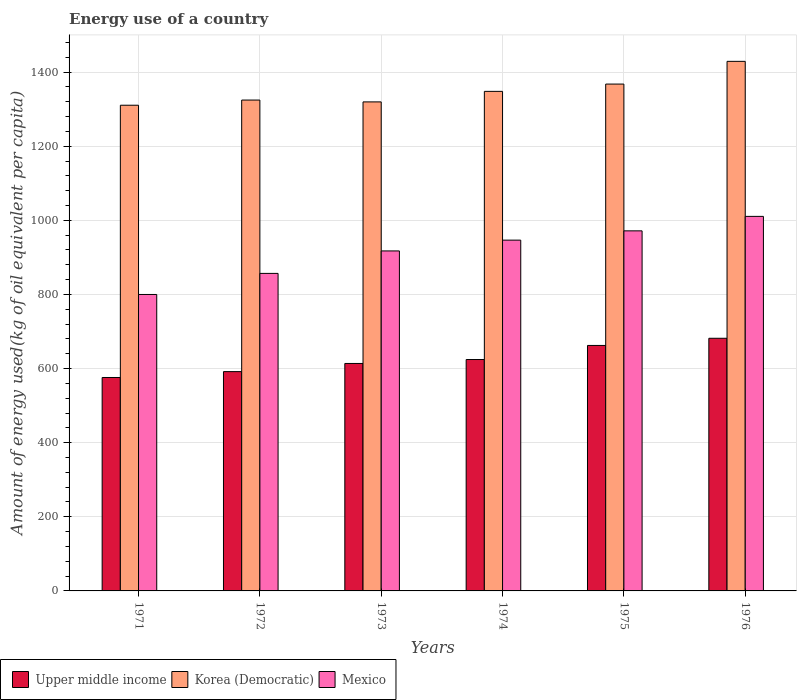How many different coloured bars are there?
Your response must be concise. 3. How many groups of bars are there?
Your response must be concise. 6. Are the number of bars per tick equal to the number of legend labels?
Keep it short and to the point. Yes. How many bars are there on the 4th tick from the left?
Your answer should be very brief. 3. How many bars are there on the 5th tick from the right?
Offer a terse response. 3. What is the label of the 5th group of bars from the left?
Your answer should be very brief. 1975. What is the amount of energy used in in Korea (Democratic) in 1971?
Provide a succinct answer. 1310.63. Across all years, what is the maximum amount of energy used in in Upper middle income?
Offer a very short reply. 681.74. Across all years, what is the minimum amount of energy used in in Korea (Democratic)?
Your answer should be compact. 1310.63. In which year was the amount of energy used in in Mexico maximum?
Ensure brevity in your answer.  1976. In which year was the amount of energy used in in Korea (Democratic) minimum?
Keep it short and to the point. 1971. What is the total amount of energy used in in Mexico in the graph?
Make the answer very short. 5503.14. What is the difference between the amount of energy used in in Upper middle income in 1972 and that in 1975?
Offer a terse response. -70.61. What is the difference between the amount of energy used in in Mexico in 1974 and the amount of energy used in in Upper middle income in 1972?
Offer a terse response. 354.8. What is the average amount of energy used in in Korea (Democratic) per year?
Give a very brief answer. 1349.94. In the year 1975, what is the difference between the amount of energy used in in Korea (Democratic) and amount of energy used in in Upper middle income?
Your answer should be very brief. 705.3. In how many years, is the amount of energy used in in Korea (Democratic) greater than 800 kg?
Ensure brevity in your answer.  6. What is the ratio of the amount of energy used in in Mexico in 1974 to that in 1975?
Give a very brief answer. 0.97. Is the amount of energy used in in Upper middle income in 1971 less than that in 1974?
Your response must be concise. Yes. What is the difference between the highest and the second highest amount of energy used in in Upper middle income?
Offer a terse response. 19.33. What is the difference between the highest and the lowest amount of energy used in in Mexico?
Provide a succinct answer. 210.75. In how many years, is the amount of energy used in in Korea (Democratic) greater than the average amount of energy used in in Korea (Democratic) taken over all years?
Your response must be concise. 2. What does the 2nd bar from the right in 1976 represents?
Provide a succinct answer. Korea (Democratic). Are all the bars in the graph horizontal?
Give a very brief answer. No. What is the difference between two consecutive major ticks on the Y-axis?
Provide a short and direct response. 200. Does the graph contain grids?
Offer a very short reply. Yes. What is the title of the graph?
Your answer should be very brief. Energy use of a country. What is the label or title of the X-axis?
Offer a very short reply. Years. What is the label or title of the Y-axis?
Make the answer very short. Amount of energy used(kg of oil equivalent per capita). What is the Amount of energy used(kg of oil equivalent per capita) of Upper middle income in 1971?
Offer a terse response. 575.93. What is the Amount of energy used(kg of oil equivalent per capita) of Korea (Democratic) in 1971?
Your response must be concise. 1310.63. What is the Amount of energy used(kg of oil equivalent per capita) of Mexico in 1971?
Your answer should be compact. 799.94. What is the Amount of energy used(kg of oil equivalent per capita) of Upper middle income in 1972?
Offer a very short reply. 591.8. What is the Amount of energy used(kg of oil equivalent per capita) of Korea (Democratic) in 1972?
Provide a short and direct response. 1324.59. What is the Amount of energy used(kg of oil equivalent per capita) of Mexico in 1972?
Your answer should be compact. 856.81. What is the Amount of energy used(kg of oil equivalent per capita) in Upper middle income in 1973?
Provide a short and direct response. 613.81. What is the Amount of energy used(kg of oil equivalent per capita) of Korea (Democratic) in 1973?
Give a very brief answer. 1319.63. What is the Amount of energy used(kg of oil equivalent per capita) of Mexico in 1973?
Your answer should be very brief. 917.47. What is the Amount of energy used(kg of oil equivalent per capita) in Upper middle income in 1974?
Provide a short and direct response. 624.42. What is the Amount of energy used(kg of oil equivalent per capita) of Korea (Democratic) in 1974?
Your answer should be compact. 1348.04. What is the Amount of energy used(kg of oil equivalent per capita) in Mexico in 1974?
Offer a terse response. 946.6. What is the Amount of energy used(kg of oil equivalent per capita) in Upper middle income in 1975?
Offer a terse response. 662.41. What is the Amount of energy used(kg of oil equivalent per capita) in Korea (Democratic) in 1975?
Ensure brevity in your answer.  1367.71. What is the Amount of energy used(kg of oil equivalent per capita) in Mexico in 1975?
Your answer should be very brief. 971.61. What is the Amount of energy used(kg of oil equivalent per capita) in Upper middle income in 1976?
Provide a succinct answer. 681.74. What is the Amount of energy used(kg of oil equivalent per capita) in Korea (Democratic) in 1976?
Offer a terse response. 1429.02. What is the Amount of energy used(kg of oil equivalent per capita) in Mexico in 1976?
Provide a succinct answer. 1010.7. Across all years, what is the maximum Amount of energy used(kg of oil equivalent per capita) of Upper middle income?
Provide a short and direct response. 681.74. Across all years, what is the maximum Amount of energy used(kg of oil equivalent per capita) in Korea (Democratic)?
Provide a short and direct response. 1429.02. Across all years, what is the maximum Amount of energy used(kg of oil equivalent per capita) in Mexico?
Your answer should be very brief. 1010.7. Across all years, what is the minimum Amount of energy used(kg of oil equivalent per capita) of Upper middle income?
Provide a short and direct response. 575.93. Across all years, what is the minimum Amount of energy used(kg of oil equivalent per capita) in Korea (Democratic)?
Ensure brevity in your answer.  1310.63. Across all years, what is the minimum Amount of energy used(kg of oil equivalent per capita) in Mexico?
Your response must be concise. 799.94. What is the total Amount of energy used(kg of oil equivalent per capita) of Upper middle income in the graph?
Provide a succinct answer. 3750.12. What is the total Amount of energy used(kg of oil equivalent per capita) of Korea (Democratic) in the graph?
Keep it short and to the point. 8099.61. What is the total Amount of energy used(kg of oil equivalent per capita) of Mexico in the graph?
Give a very brief answer. 5503.14. What is the difference between the Amount of energy used(kg of oil equivalent per capita) of Upper middle income in 1971 and that in 1972?
Offer a very short reply. -15.87. What is the difference between the Amount of energy used(kg of oil equivalent per capita) of Korea (Democratic) in 1971 and that in 1972?
Ensure brevity in your answer.  -13.96. What is the difference between the Amount of energy used(kg of oil equivalent per capita) in Mexico in 1971 and that in 1972?
Offer a very short reply. -56.87. What is the difference between the Amount of energy used(kg of oil equivalent per capita) of Upper middle income in 1971 and that in 1973?
Offer a very short reply. -37.88. What is the difference between the Amount of energy used(kg of oil equivalent per capita) in Korea (Democratic) in 1971 and that in 1973?
Make the answer very short. -9. What is the difference between the Amount of energy used(kg of oil equivalent per capita) in Mexico in 1971 and that in 1973?
Offer a very short reply. -117.53. What is the difference between the Amount of energy used(kg of oil equivalent per capita) of Upper middle income in 1971 and that in 1974?
Offer a very short reply. -48.49. What is the difference between the Amount of energy used(kg of oil equivalent per capita) of Korea (Democratic) in 1971 and that in 1974?
Your response must be concise. -37.41. What is the difference between the Amount of energy used(kg of oil equivalent per capita) of Mexico in 1971 and that in 1974?
Your answer should be very brief. -146.66. What is the difference between the Amount of energy used(kg of oil equivalent per capita) of Upper middle income in 1971 and that in 1975?
Your answer should be very brief. -86.48. What is the difference between the Amount of energy used(kg of oil equivalent per capita) in Korea (Democratic) in 1971 and that in 1975?
Offer a very short reply. -57.08. What is the difference between the Amount of energy used(kg of oil equivalent per capita) in Mexico in 1971 and that in 1975?
Your answer should be compact. -171.67. What is the difference between the Amount of energy used(kg of oil equivalent per capita) in Upper middle income in 1971 and that in 1976?
Offer a very short reply. -105.81. What is the difference between the Amount of energy used(kg of oil equivalent per capita) of Korea (Democratic) in 1971 and that in 1976?
Ensure brevity in your answer.  -118.39. What is the difference between the Amount of energy used(kg of oil equivalent per capita) in Mexico in 1971 and that in 1976?
Keep it short and to the point. -210.75. What is the difference between the Amount of energy used(kg of oil equivalent per capita) in Upper middle income in 1972 and that in 1973?
Offer a terse response. -22.02. What is the difference between the Amount of energy used(kg of oil equivalent per capita) in Korea (Democratic) in 1972 and that in 1973?
Offer a terse response. 4.97. What is the difference between the Amount of energy used(kg of oil equivalent per capita) in Mexico in 1972 and that in 1973?
Your answer should be very brief. -60.66. What is the difference between the Amount of energy used(kg of oil equivalent per capita) of Upper middle income in 1972 and that in 1974?
Your response must be concise. -32.63. What is the difference between the Amount of energy used(kg of oil equivalent per capita) of Korea (Democratic) in 1972 and that in 1974?
Ensure brevity in your answer.  -23.44. What is the difference between the Amount of energy used(kg of oil equivalent per capita) in Mexico in 1972 and that in 1974?
Keep it short and to the point. -89.79. What is the difference between the Amount of energy used(kg of oil equivalent per capita) in Upper middle income in 1972 and that in 1975?
Ensure brevity in your answer.  -70.61. What is the difference between the Amount of energy used(kg of oil equivalent per capita) in Korea (Democratic) in 1972 and that in 1975?
Give a very brief answer. -43.12. What is the difference between the Amount of energy used(kg of oil equivalent per capita) of Mexico in 1972 and that in 1975?
Keep it short and to the point. -114.8. What is the difference between the Amount of energy used(kg of oil equivalent per capita) in Upper middle income in 1972 and that in 1976?
Offer a terse response. -89.94. What is the difference between the Amount of energy used(kg of oil equivalent per capita) in Korea (Democratic) in 1972 and that in 1976?
Ensure brevity in your answer.  -104.43. What is the difference between the Amount of energy used(kg of oil equivalent per capita) of Mexico in 1972 and that in 1976?
Your answer should be very brief. -153.89. What is the difference between the Amount of energy used(kg of oil equivalent per capita) in Upper middle income in 1973 and that in 1974?
Your answer should be compact. -10.61. What is the difference between the Amount of energy used(kg of oil equivalent per capita) of Korea (Democratic) in 1973 and that in 1974?
Offer a terse response. -28.41. What is the difference between the Amount of energy used(kg of oil equivalent per capita) in Mexico in 1973 and that in 1974?
Your answer should be compact. -29.13. What is the difference between the Amount of energy used(kg of oil equivalent per capita) of Upper middle income in 1973 and that in 1975?
Your answer should be compact. -48.6. What is the difference between the Amount of energy used(kg of oil equivalent per capita) of Korea (Democratic) in 1973 and that in 1975?
Ensure brevity in your answer.  -48.08. What is the difference between the Amount of energy used(kg of oil equivalent per capita) in Mexico in 1973 and that in 1975?
Your response must be concise. -54.14. What is the difference between the Amount of energy used(kg of oil equivalent per capita) of Upper middle income in 1973 and that in 1976?
Your answer should be very brief. -67.93. What is the difference between the Amount of energy used(kg of oil equivalent per capita) of Korea (Democratic) in 1973 and that in 1976?
Your answer should be very brief. -109.39. What is the difference between the Amount of energy used(kg of oil equivalent per capita) in Mexico in 1973 and that in 1976?
Ensure brevity in your answer.  -93.23. What is the difference between the Amount of energy used(kg of oil equivalent per capita) of Upper middle income in 1974 and that in 1975?
Provide a succinct answer. -37.99. What is the difference between the Amount of energy used(kg of oil equivalent per capita) of Korea (Democratic) in 1974 and that in 1975?
Your response must be concise. -19.67. What is the difference between the Amount of energy used(kg of oil equivalent per capita) of Mexico in 1974 and that in 1975?
Give a very brief answer. -25.01. What is the difference between the Amount of energy used(kg of oil equivalent per capita) of Upper middle income in 1974 and that in 1976?
Your response must be concise. -57.32. What is the difference between the Amount of energy used(kg of oil equivalent per capita) in Korea (Democratic) in 1974 and that in 1976?
Keep it short and to the point. -80.98. What is the difference between the Amount of energy used(kg of oil equivalent per capita) in Mexico in 1974 and that in 1976?
Keep it short and to the point. -64.1. What is the difference between the Amount of energy used(kg of oil equivalent per capita) in Upper middle income in 1975 and that in 1976?
Your answer should be compact. -19.33. What is the difference between the Amount of energy used(kg of oil equivalent per capita) of Korea (Democratic) in 1975 and that in 1976?
Your answer should be very brief. -61.31. What is the difference between the Amount of energy used(kg of oil equivalent per capita) of Mexico in 1975 and that in 1976?
Keep it short and to the point. -39.08. What is the difference between the Amount of energy used(kg of oil equivalent per capita) of Upper middle income in 1971 and the Amount of energy used(kg of oil equivalent per capita) of Korea (Democratic) in 1972?
Your response must be concise. -748.66. What is the difference between the Amount of energy used(kg of oil equivalent per capita) of Upper middle income in 1971 and the Amount of energy used(kg of oil equivalent per capita) of Mexico in 1972?
Ensure brevity in your answer.  -280.88. What is the difference between the Amount of energy used(kg of oil equivalent per capita) of Korea (Democratic) in 1971 and the Amount of energy used(kg of oil equivalent per capita) of Mexico in 1972?
Your response must be concise. 453.82. What is the difference between the Amount of energy used(kg of oil equivalent per capita) in Upper middle income in 1971 and the Amount of energy used(kg of oil equivalent per capita) in Korea (Democratic) in 1973?
Offer a terse response. -743.69. What is the difference between the Amount of energy used(kg of oil equivalent per capita) of Upper middle income in 1971 and the Amount of energy used(kg of oil equivalent per capita) of Mexico in 1973?
Offer a very short reply. -341.54. What is the difference between the Amount of energy used(kg of oil equivalent per capita) in Korea (Democratic) in 1971 and the Amount of energy used(kg of oil equivalent per capita) in Mexico in 1973?
Your response must be concise. 393.16. What is the difference between the Amount of energy used(kg of oil equivalent per capita) in Upper middle income in 1971 and the Amount of energy used(kg of oil equivalent per capita) in Korea (Democratic) in 1974?
Your response must be concise. -772.11. What is the difference between the Amount of energy used(kg of oil equivalent per capita) of Upper middle income in 1971 and the Amount of energy used(kg of oil equivalent per capita) of Mexico in 1974?
Provide a succinct answer. -370.67. What is the difference between the Amount of energy used(kg of oil equivalent per capita) of Korea (Democratic) in 1971 and the Amount of energy used(kg of oil equivalent per capita) of Mexico in 1974?
Provide a short and direct response. 364.03. What is the difference between the Amount of energy used(kg of oil equivalent per capita) in Upper middle income in 1971 and the Amount of energy used(kg of oil equivalent per capita) in Korea (Democratic) in 1975?
Give a very brief answer. -791.78. What is the difference between the Amount of energy used(kg of oil equivalent per capita) in Upper middle income in 1971 and the Amount of energy used(kg of oil equivalent per capita) in Mexico in 1975?
Your answer should be very brief. -395.68. What is the difference between the Amount of energy used(kg of oil equivalent per capita) in Korea (Democratic) in 1971 and the Amount of energy used(kg of oil equivalent per capita) in Mexico in 1975?
Keep it short and to the point. 339.01. What is the difference between the Amount of energy used(kg of oil equivalent per capita) of Upper middle income in 1971 and the Amount of energy used(kg of oil equivalent per capita) of Korea (Democratic) in 1976?
Your answer should be compact. -853.09. What is the difference between the Amount of energy used(kg of oil equivalent per capita) of Upper middle income in 1971 and the Amount of energy used(kg of oil equivalent per capita) of Mexico in 1976?
Your response must be concise. -434.77. What is the difference between the Amount of energy used(kg of oil equivalent per capita) of Korea (Democratic) in 1971 and the Amount of energy used(kg of oil equivalent per capita) of Mexico in 1976?
Provide a short and direct response. 299.93. What is the difference between the Amount of energy used(kg of oil equivalent per capita) in Upper middle income in 1972 and the Amount of energy used(kg of oil equivalent per capita) in Korea (Democratic) in 1973?
Provide a short and direct response. -727.83. What is the difference between the Amount of energy used(kg of oil equivalent per capita) of Upper middle income in 1972 and the Amount of energy used(kg of oil equivalent per capita) of Mexico in 1973?
Your response must be concise. -325.67. What is the difference between the Amount of energy used(kg of oil equivalent per capita) of Korea (Democratic) in 1972 and the Amount of energy used(kg of oil equivalent per capita) of Mexico in 1973?
Offer a very short reply. 407.12. What is the difference between the Amount of energy used(kg of oil equivalent per capita) in Upper middle income in 1972 and the Amount of energy used(kg of oil equivalent per capita) in Korea (Democratic) in 1974?
Ensure brevity in your answer.  -756.24. What is the difference between the Amount of energy used(kg of oil equivalent per capita) of Upper middle income in 1972 and the Amount of energy used(kg of oil equivalent per capita) of Mexico in 1974?
Give a very brief answer. -354.8. What is the difference between the Amount of energy used(kg of oil equivalent per capita) of Korea (Democratic) in 1972 and the Amount of energy used(kg of oil equivalent per capita) of Mexico in 1974?
Offer a terse response. 377.99. What is the difference between the Amount of energy used(kg of oil equivalent per capita) in Upper middle income in 1972 and the Amount of energy used(kg of oil equivalent per capita) in Korea (Democratic) in 1975?
Your answer should be compact. -775.91. What is the difference between the Amount of energy used(kg of oil equivalent per capita) in Upper middle income in 1972 and the Amount of energy used(kg of oil equivalent per capita) in Mexico in 1975?
Provide a short and direct response. -379.82. What is the difference between the Amount of energy used(kg of oil equivalent per capita) of Korea (Democratic) in 1972 and the Amount of energy used(kg of oil equivalent per capita) of Mexico in 1975?
Make the answer very short. 352.98. What is the difference between the Amount of energy used(kg of oil equivalent per capita) of Upper middle income in 1972 and the Amount of energy used(kg of oil equivalent per capita) of Korea (Democratic) in 1976?
Ensure brevity in your answer.  -837.22. What is the difference between the Amount of energy used(kg of oil equivalent per capita) of Upper middle income in 1972 and the Amount of energy used(kg of oil equivalent per capita) of Mexico in 1976?
Offer a terse response. -418.9. What is the difference between the Amount of energy used(kg of oil equivalent per capita) of Korea (Democratic) in 1972 and the Amount of energy used(kg of oil equivalent per capita) of Mexico in 1976?
Provide a succinct answer. 313.89. What is the difference between the Amount of energy used(kg of oil equivalent per capita) in Upper middle income in 1973 and the Amount of energy used(kg of oil equivalent per capita) in Korea (Democratic) in 1974?
Provide a short and direct response. -734.22. What is the difference between the Amount of energy used(kg of oil equivalent per capita) in Upper middle income in 1973 and the Amount of energy used(kg of oil equivalent per capita) in Mexico in 1974?
Your answer should be compact. -332.79. What is the difference between the Amount of energy used(kg of oil equivalent per capita) in Korea (Democratic) in 1973 and the Amount of energy used(kg of oil equivalent per capita) in Mexico in 1974?
Your answer should be very brief. 373.02. What is the difference between the Amount of energy used(kg of oil equivalent per capita) in Upper middle income in 1973 and the Amount of energy used(kg of oil equivalent per capita) in Korea (Democratic) in 1975?
Your answer should be compact. -753.9. What is the difference between the Amount of energy used(kg of oil equivalent per capita) in Upper middle income in 1973 and the Amount of energy used(kg of oil equivalent per capita) in Mexico in 1975?
Make the answer very short. -357.8. What is the difference between the Amount of energy used(kg of oil equivalent per capita) of Korea (Democratic) in 1973 and the Amount of energy used(kg of oil equivalent per capita) of Mexico in 1975?
Make the answer very short. 348.01. What is the difference between the Amount of energy used(kg of oil equivalent per capita) in Upper middle income in 1973 and the Amount of energy used(kg of oil equivalent per capita) in Korea (Democratic) in 1976?
Provide a succinct answer. -815.2. What is the difference between the Amount of energy used(kg of oil equivalent per capita) of Upper middle income in 1973 and the Amount of energy used(kg of oil equivalent per capita) of Mexico in 1976?
Ensure brevity in your answer.  -396.88. What is the difference between the Amount of energy used(kg of oil equivalent per capita) in Korea (Democratic) in 1973 and the Amount of energy used(kg of oil equivalent per capita) in Mexico in 1976?
Provide a short and direct response. 308.93. What is the difference between the Amount of energy used(kg of oil equivalent per capita) of Upper middle income in 1974 and the Amount of energy used(kg of oil equivalent per capita) of Korea (Democratic) in 1975?
Offer a terse response. -743.28. What is the difference between the Amount of energy used(kg of oil equivalent per capita) of Upper middle income in 1974 and the Amount of energy used(kg of oil equivalent per capita) of Mexico in 1975?
Ensure brevity in your answer.  -347.19. What is the difference between the Amount of energy used(kg of oil equivalent per capita) in Korea (Democratic) in 1974 and the Amount of energy used(kg of oil equivalent per capita) in Mexico in 1975?
Provide a succinct answer. 376.42. What is the difference between the Amount of energy used(kg of oil equivalent per capita) of Upper middle income in 1974 and the Amount of energy used(kg of oil equivalent per capita) of Korea (Democratic) in 1976?
Your response must be concise. -804.59. What is the difference between the Amount of energy used(kg of oil equivalent per capita) in Upper middle income in 1974 and the Amount of energy used(kg of oil equivalent per capita) in Mexico in 1976?
Your answer should be compact. -386.27. What is the difference between the Amount of energy used(kg of oil equivalent per capita) in Korea (Democratic) in 1974 and the Amount of energy used(kg of oil equivalent per capita) in Mexico in 1976?
Offer a very short reply. 337.34. What is the difference between the Amount of energy used(kg of oil equivalent per capita) of Upper middle income in 1975 and the Amount of energy used(kg of oil equivalent per capita) of Korea (Democratic) in 1976?
Your answer should be very brief. -766.61. What is the difference between the Amount of energy used(kg of oil equivalent per capita) of Upper middle income in 1975 and the Amount of energy used(kg of oil equivalent per capita) of Mexico in 1976?
Ensure brevity in your answer.  -348.29. What is the difference between the Amount of energy used(kg of oil equivalent per capita) in Korea (Democratic) in 1975 and the Amount of energy used(kg of oil equivalent per capita) in Mexico in 1976?
Your response must be concise. 357.01. What is the average Amount of energy used(kg of oil equivalent per capita) in Upper middle income per year?
Make the answer very short. 625.02. What is the average Amount of energy used(kg of oil equivalent per capita) of Korea (Democratic) per year?
Provide a short and direct response. 1349.94. What is the average Amount of energy used(kg of oil equivalent per capita) of Mexico per year?
Offer a very short reply. 917.19. In the year 1971, what is the difference between the Amount of energy used(kg of oil equivalent per capita) in Upper middle income and Amount of energy used(kg of oil equivalent per capita) in Korea (Democratic)?
Your answer should be very brief. -734.7. In the year 1971, what is the difference between the Amount of energy used(kg of oil equivalent per capita) in Upper middle income and Amount of energy used(kg of oil equivalent per capita) in Mexico?
Ensure brevity in your answer.  -224.01. In the year 1971, what is the difference between the Amount of energy used(kg of oil equivalent per capita) of Korea (Democratic) and Amount of energy used(kg of oil equivalent per capita) of Mexico?
Offer a very short reply. 510.68. In the year 1972, what is the difference between the Amount of energy used(kg of oil equivalent per capita) in Upper middle income and Amount of energy used(kg of oil equivalent per capita) in Korea (Democratic)?
Keep it short and to the point. -732.79. In the year 1972, what is the difference between the Amount of energy used(kg of oil equivalent per capita) of Upper middle income and Amount of energy used(kg of oil equivalent per capita) of Mexico?
Provide a short and direct response. -265.01. In the year 1972, what is the difference between the Amount of energy used(kg of oil equivalent per capita) of Korea (Democratic) and Amount of energy used(kg of oil equivalent per capita) of Mexico?
Your answer should be compact. 467.78. In the year 1973, what is the difference between the Amount of energy used(kg of oil equivalent per capita) of Upper middle income and Amount of energy used(kg of oil equivalent per capita) of Korea (Democratic)?
Make the answer very short. -705.81. In the year 1973, what is the difference between the Amount of energy used(kg of oil equivalent per capita) in Upper middle income and Amount of energy used(kg of oil equivalent per capita) in Mexico?
Your answer should be very brief. -303.66. In the year 1973, what is the difference between the Amount of energy used(kg of oil equivalent per capita) of Korea (Democratic) and Amount of energy used(kg of oil equivalent per capita) of Mexico?
Your answer should be compact. 402.15. In the year 1974, what is the difference between the Amount of energy used(kg of oil equivalent per capita) in Upper middle income and Amount of energy used(kg of oil equivalent per capita) in Korea (Democratic)?
Ensure brevity in your answer.  -723.61. In the year 1974, what is the difference between the Amount of energy used(kg of oil equivalent per capita) in Upper middle income and Amount of energy used(kg of oil equivalent per capita) in Mexico?
Give a very brief answer. -322.18. In the year 1974, what is the difference between the Amount of energy used(kg of oil equivalent per capita) in Korea (Democratic) and Amount of energy used(kg of oil equivalent per capita) in Mexico?
Make the answer very short. 401.44. In the year 1975, what is the difference between the Amount of energy used(kg of oil equivalent per capita) in Upper middle income and Amount of energy used(kg of oil equivalent per capita) in Korea (Democratic)?
Make the answer very short. -705.3. In the year 1975, what is the difference between the Amount of energy used(kg of oil equivalent per capita) of Upper middle income and Amount of energy used(kg of oil equivalent per capita) of Mexico?
Offer a terse response. -309.2. In the year 1975, what is the difference between the Amount of energy used(kg of oil equivalent per capita) of Korea (Democratic) and Amount of energy used(kg of oil equivalent per capita) of Mexico?
Give a very brief answer. 396.09. In the year 1976, what is the difference between the Amount of energy used(kg of oil equivalent per capita) in Upper middle income and Amount of energy used(kg of oil equivalent per capita) in Korea (Democratic)?
Your answer should be compact. -747.28. In the year 1976, what is the difference between the Amount of energy used(kg of oil equivalent per capita) in Upper middle income and Amount of energy used(kg of oil equivalent per capita) in Mexico?
Offer a very short reply. -328.96. In the year 1976, what is the difference between the Amount of energy used(kg of oil equivalent per capita) in Korea (Democratic) and Amount of energy used(kg of oil equivalent per capita) in Mexico?
Your answer should be compact. 418.32. What is the ratio of the Amount of energy used(kg of oil equivalent per capita) of Upper middle income in 1971 to that in 1972?
Your answer should be compact. 0.97. What is the ratio of the Amount of energy used(kg of oil equivalent per capita) of Mexico in 1971 to that in 1972?
Provide a short and direct response. 0.93. What is the ratio of the Amount of energy used(kg of oil equivalent per capita) of Upper middle income in 1971 to that in 1973?
Offer a very short reply. 0.94. What is the ratio of the Amount of energy used(kg of oil equivalent per capita) of Mexico in 1971 to that in 1973?
Your answer should be compact. 0.87. What is the ratio of the Amount of energy used(kg of oil equivalent per capita) in Upper middle income in 1971 to that in 1974?
Your answer should be compact. 0.92. What is the ratio of the Amount of energy used(kg of oil equivalent per capita) of Korea (Democratic) in 1971 to that in 1974?
Make the answer very short. 0.97. What is the ratio of the Amount of energy used(kg of oil equivalent per capita) in Mexico in 1971 to that in 1974?
Make the answer very short. 0.85. What is the ratio of the Amount of energy used(kg of oil equivalent per capita) of Upper middle income in 1971 to that in 1975?
Give a very brief answer. 0.87. What is the ratio of the Amount of energy used(kg of oil equivalent per capita) of Korea (Democratic) in 1971 to that in 1975?
Make the answer very short. 0.96. What is the ratio of the Amount of energy used(kg of oil equivalent per capita) of Mexico in 1971 to that in 1975?
Your answer should be compact. 0.82. What is the ratio of the Amount of energy used(kg of oil equivalent per capita) of Upper middle income in 1971 to that in 1976?
Your response must be concise. 0.84. What is the ratio of the Amount of energy used(kg of oil equivalent per capita) of Korea (Democratic) in 1971 to that in 1976?
Your answer should be very brief. 0.92. What is the ratio of the Amount of energy used(kg of oil equivalent per capita) in Mexico in 1971 to that in 1976?
Keep it short and to the point. 0.79. What is the ratio of the Amount of energy used(kg of oil equivalent per capita) in Upper middle income in 1972 to that in 1973?
Give a very brief answer. 0.96. What is the ratio of the Amount of energy used(kg of oil equivalent per capita) in Korea (Democratic) in 1972 to that in 1973?
Provide a short and direct response. 1. What is the ratio of the Amount of energy used(kg of oil equivalent per capita) in Mexico in 1972 to that in 1973?
Offer a terse response. 0.93. What is the ratio of the Amount of energy used(kg of oil equivalent per capita) of Upper middle income in 1972 to that in 1974?
Offer a terse response. 0.95. What is the ratio of the Amount of energy used(kg of oil equivalent per capita) of Korea (Democratic) in 1972 to that in 1974?
Keep it short and to the point. 0.98. What is the ratio of the Amount of energy used(kg of oil equivalent per capita) of Mexico in 1972 to that in 1974?
Your answer should be compact. 0.91. What is the ratio of the Amount of energy used(kg of oil equivalent per capita) of Upper middle income in 1972 to that in 1975?
Make the answer very short. 0.89. What is the ratio of the Amount of energy used(kg of oil equivalent per capita) in Korea (Democratic) in 1972 to that in 1975?
Give a very brief answer. 0.97. What is the ratio of the Amount of energy used(kg of oil equivalent per capita) of Mexico in 1972 to that in 1975?
Offer a very short reply. 0.88. What is the ratio of the Amount of energy used(kg of oil equivalent per capita) in Upper middle income in 1972 to that in 1976?
Provide a succinct answer. 0.87. What is the ratio of the Amount of energy used(kg of oil equivalent per capita) of Korea (Democratic) in 1972 to that in 1976?
Make the answer very short. 0.93. What is the ratio of the Amount of energy used(kg of oil equivalent per capita) of Mexico in 1972 to that in 1976?
Keep it short and to the point. 0.85. What is the ratio of the Amount of energy used(kg of oil equivalent per capita) in Upper middle income in 1973 to that in 1974?
Give a very brief answer. 0.98. What is the ratio of the Amount of energy used(kg of oil equivalent per capita) of Korea (Democratic) in 1973 to that in 1974?
Your response must be concise. 0.98. What is the ratio of the Amount of energy used(kg of oil equivalent per capita) in Mexico in 1973 to that in 1974?
Offer a terse response. 0.97. What is the ratio of the Amount of energy used(kg of oil equivalent per capita) of Upper middle income in 1973 to that in 1975?
Your answer should be very brief. 0.93. What is the ratio of the Amount of energy used(kg of oil equivalent per capita) of Korea (Democratic) in 1973 to that in 1975?
Your response must be concise. 0.96. What is the ratio of the Amount of energy used(kg of oil equivalent per capita) in Mexico in 1973 to that in 1975?
Your answer should be compact. 0.94. What is the ratio of the Amount of energy used(kg of oil equivalent per capita) in Upper middle income in 1973 to that in 1976?
Give a very brief answer. 0.9. What is the ratio of the Amount of energy used(kg of oil equivalent per capita) of Korea (Democratic) in 1973 to that in 1976?
Your response must be concise. 0.92. What is the ratio of the Amount of energy used(kg of oil equivalent per capita) of Mexico in 1973 to that in 1976?
Offer a terse response. 0.91. What is the ratio of the Amount of energy used(kg of oil equivalent per capita) in Upper middle income in 1974 to that in 1975?
Your answer should be very brief. 0.94. What is the ratio of the Amount of energy used(kg of oil equivalent per capita) of Korea (Democratic) in 1974 to that in 1975?
Provide a succinct answer. 0.99. What is the ratio of the Amount of energy used(kg of oil equivalent per capita) in Mexico in 1974 to that in 1975?
Provide a succinct answer. 0.97. What is the ratio of the Amount of energy used(kg of oil equivalent per capita) in Upper middle income in 1974 to that in 1976?
Give a very brief answer. 0.92. What is the ratio of the Amount of energy used(kg of oil equivalent per capita) in Korea (Democratic) in 1974 to that in 1976?
Offer a very short reply. 0.94. What is the ratio of the Amount of energy used(kg of oil equivalent per capita) in Mexico in 1974 to that in 1976?
Provide a short and direct response. 0.94. What is the ratio of the Amount of energy used(kg of oil equivalent per capita) in Upper middle income in 1975 to that in 1976?
Your response must be concise. 0.97. What is the ratio of the Amount of energy used(kg of oil equivalent per capita) in Korea (Democratic) in 1975 to that in 1976?
Offer a terse response. 0.96. What is the ratio of the Amount of energy used(kg of oil equivalent per capita) in Mexico in 1975 to that in 1976?
Provide a succinct answer. 0.96. What is the difference between the highest and the second highest Amount of energy used(kg of oil equivalent per capita) in Upper middle income?
Provide a succinct answer. 19.33. What is the difference between the highest and the second highest Amount of energy used(kg of oil equivalent per capita) in Korea (Democratic)?
Your answer should be compact. 61.31. What is the difference between the highest and the second highest Amount of energy used(kg of oil equivalent per capita) of Mexico?
Ensure brevity in your answer.  39.08. What is the difference between the highest and the lowest Amount of energy used(kg of oil equivalent per capita) of Upper middle income?
Offer a very short reply. 105.81. What is the difference between the highest and the lowest Amount of energy used(kg of oil equivalent per capita) of Korea (Democratic)?
Give a very brief answer. 118.39. What is the difference between the highest and the lowest Amount of energy used(kg of oil equivalent per capita) of Mexico?
Offer a very short reply. 210.75. 